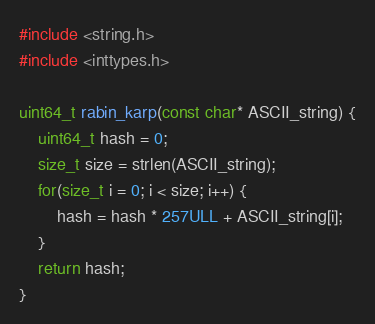Convert code to text. <code><loc_0><loc_0><loc_500><loc_500><_C_>#include <string.h>
#include <inttypes.h>

uint64_t rabin_karp(const char* ASCII_string) {
    uint64_t hash = 0;
    size_t size = strlen(ASCII_string);
    for(size_t i = 0; i < size; i++) {
        hash = hash * 257ULL + ASCII_string[i];
    }
    return hash;
}
</code> 